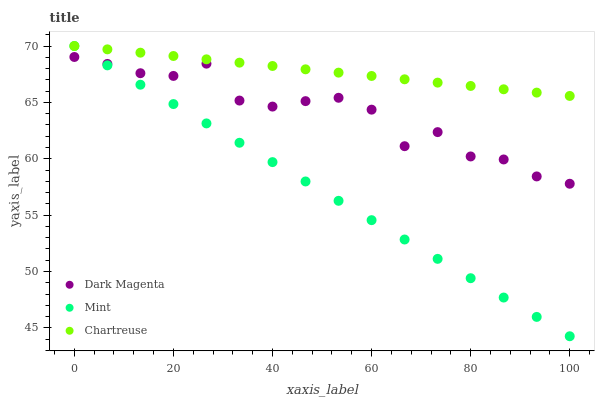Does Mint have the minimum area under the curve?
Answer yes or no. Yes. Does Chartreuse have the maximum area under the curve?
Answer yes or no. Yes. Does Dark Magenta have the minimum area under the curve?
Answer yes or no. No. Does Dark Magenta have the maximum area under the curve?
Answer yes or no. No. Is Mint the smoothest?
Answer yes or no. Yes. Is Dark Magenta the roughest?
Answer yes or no. Yes. Is Dark Magenta the smoothest?
Answer yes or no. No. Is Mint the roughest?
Answer yes or no. No. Does Mint have the lowest value?
Answer yes or no. Yes. Does Dark Magenta have the lowest value?
Answer yes or no. No. Does Mint have the highest value?
Answer yes or no. Yes. Does Dark Magenta have the highest value?
Answer yes or no. No. Is Dark Magenta less than Chartreuse?
Answer yes or no. Yes. Is Chartreuse greater than Dark Magenta?
Answer yes or no. Yes. Does Mint intersect Chartreuse?
Answer yes or no. Yes. Is Mint less than Chartreuse?
Answer yes or no. No. Is Mint greater than Chartreuse?
Answer yes or no. No. Does Dark Magenta intersect Chartreuse?
Answer yes or no. No. 